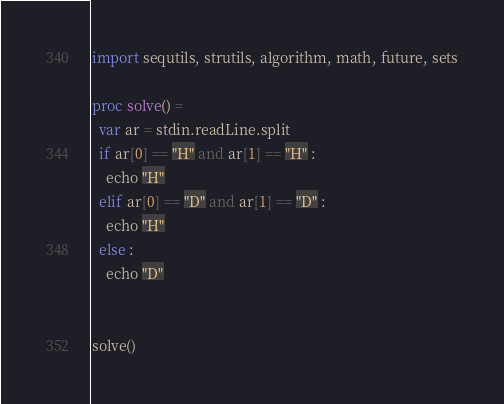<code> <loc_0><loc_0><loc_500><loc_500><_Nim_>import sequtils, strutils, algorithm, math, future, sets

proc solve() =
  var ar = stdin.readLine.split
  if ar[0] == "H" and ar[1] == "H" :
    echo "H"
  elif ar[0] == "D" and ar[1] == "D" : 
    echo "H"
  else : 
    echo "D"
  

solve()</code> 